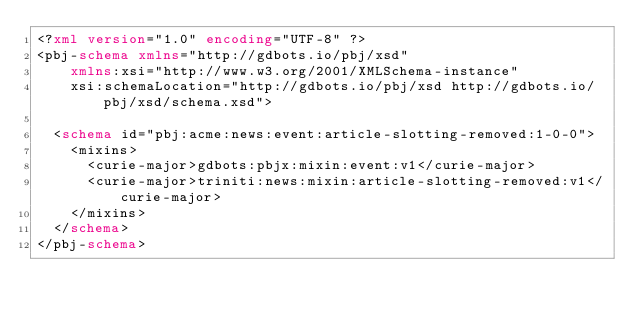<code> <loc_0><loc_0><loc_500><loc_500><_XML_><?xml version="1.0" encoding="UTF-8" ?>
<pbj-schema xmlns="http://gdbots.io/pbj/xsd"
    xmlns:xsi="http://www.w3.org/2001/XMLSchema-instance"
    xsi:schemaLocation="http://gdbots.io/pbj/xsd http://gdbots.io/pbj/xsd/schema.xsd">

  <schema id="pbj:acme:news:event:article-slotting-removed:1-0-0">
    <mixins>
      <curie-major>gdbots:pbjx:mixin:event:v1</curie-major>
      <curie-major>triniti:news:mixin:article-slotting-removed:v1</curie-major>
    </mixins>
  </schema>
</pbj-schema>
</code> 